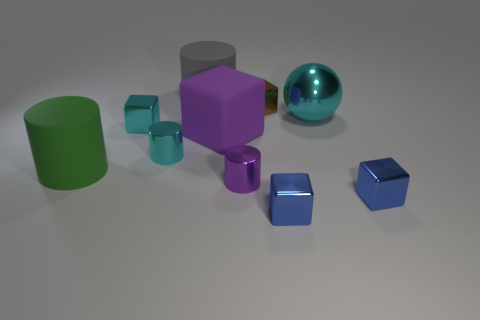What number of large objects are either brown shiny things or rubber blocks?
Provide a short and direct response. 1. What number of other objects are there of the same color as the matte cube?
Provide a short and direct response. 1. What number of small purple cylinders are behind the large thing behind the cyan metal object that is right of the purple metal cylinder?
Make the answer very short. 0. There is a shiny cylinder to the right of the purple matte object; is it the same size as the cyan cylinder?
Ensure brevity in your answer.  Yes. Is the number of tiny purple cylinders behind the cyan metallic cylinder less than the number of small shiny cylinders behind the brown block?
Provide a short and direct response. No. Is the large cube the same color as the large metallic ball?
Offer a terse response. No. Are there fewer big gray objects that are on the left side of the purple cylinder than large green objects?
Make the answer very short. No. There is a cube that is the same color as the large shiny thing; what is its material?
Make the answer very short. Metal. Are the cyan sphere and the brown thing made of the same material?
Offer a terse response. Yes. What number of gray cylinders have the same material as the big purple block?
Provide a short and direct response. 1. 